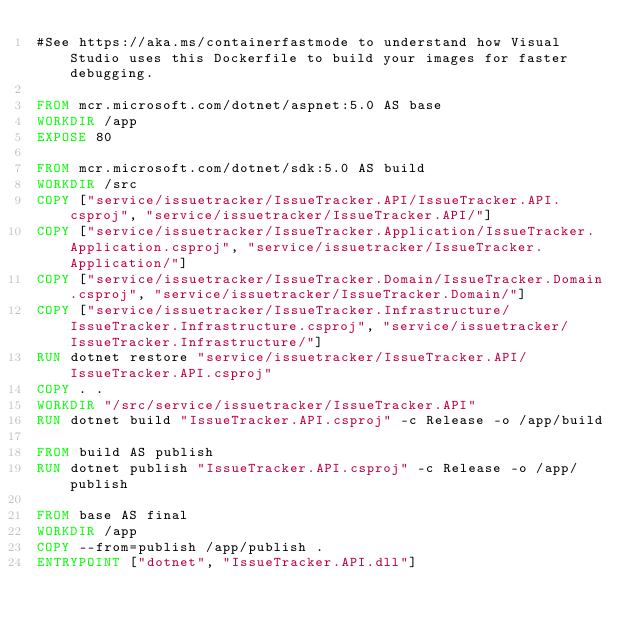Convert code to text. <code><loc_0><loc_0><loc_500><loc_500><_Dockerfile_>#See https://aka.ms/containerfastmode to understand how Visual Studio uses this Dockerfile to build your images for faster debugging.

FROM mcr.microsoft.com/dotnet/aspnet:5.0 AS base
WORKDIR /app
EXPOSE 80

FROM mcr.microsoft.com/dotnet/sdk:5.0 AS build
WORKDIR /src
COPY ["service/issuetracker/IssueTracker.API/IssueTracker.API.csproj", "service/issuetracker/IssueTracker.API/"]
COPY ["service/issuetracker/IssueTracker.Application/IssueTracker.Application.csproj", "service/issuetracker/IssueTracker.Application/"]
COPY ["service/issuetracker/IssueTracker.Domain/IssueTracker.Domain.csproj", "service/issuetracker/IssueTracker.Domain/"]
COPY ["service/issuetracker/IssueTracker.Infrastructure/IssueTracker.Infrastructure.csproj", "service/issuetracker/IssueTracker.Infrastructure/"]
RUN dotnet restore "service/issuetracker/IssueTracker.API/IssueTracker.API.csproj"
COPY . .
WORKDIR "/src/service/issuetracker/IssueTracker.API"
RUN dotnet build "IssueTracker.API.csproj" -c Release -o /app/build

FROM build AS publish
RUN dotnet publish "IssueTracker.API.csproj" -c Release -o /app/publish

FROM base AS final
WORKDIR /app
COPY --from=publish /app/publish .
ENTRYPOINT ["dotnet", "IssueTracker.API.dll"]</code> 